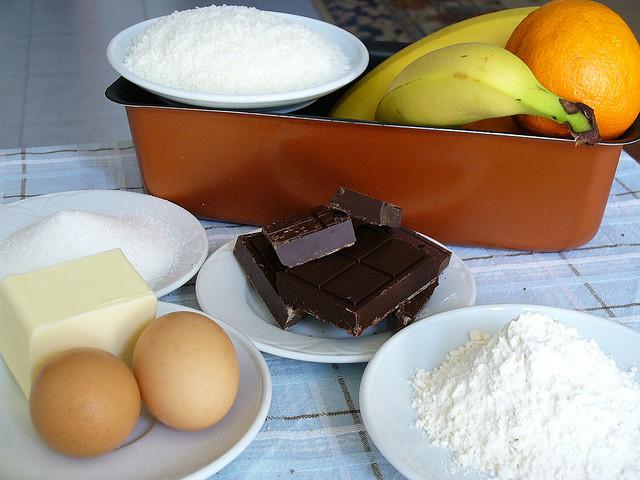How many dishes are there?
Short answer required. 5. What kind of candy is in the photo?
Be succinct. Chocolate. What fruit is on the right?
Short answer required. Orange. How many pieces of chocolate are on the plate?
Keep it brief. 5. 